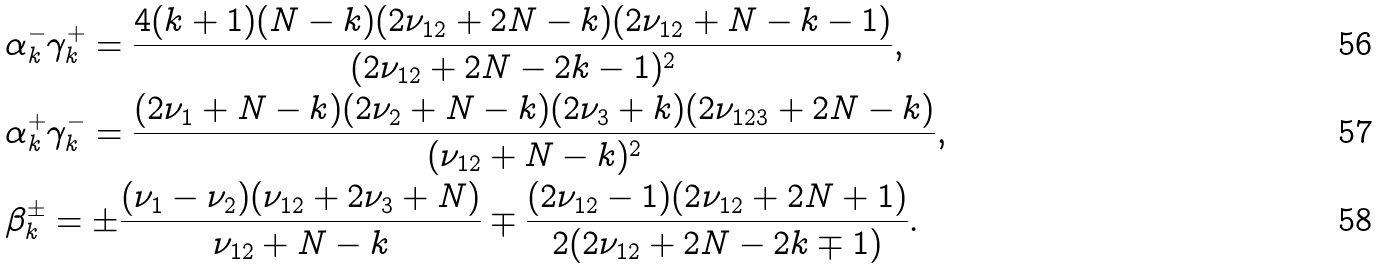Convert formula to latex. <formula><loc_0><loc_0><loc_500><loc_500>& \alpha ^ { - } _ { k } \gamma _ { k } ^ { + } = \frac { 4 ( k + 1 ) ( N - k ) ( 2 \nu _ { 1 2 } + 2 N - k ) ( 2 \nu _ { 1 2 } + N - k - 1 ) } { ( 2 \nu _ { 1 2 } + 2 N - 2 k - 1 ) ^ { 2 } } , \\ & \alpha ^ { + } _ { k } \gamma _ { k } ^ { - } = \frac { ( 2 \nu _ { 1 } + N - k ) ( 2 \nu _ { 2 } + N - k ) ( 2 \nu _ { 3 } + k ) ( 2 \nu _ { 1 2 3 } + 2 N - k ) } { ( \nu _ { 1 2 } + N - k ) ^ { 2 } } , \\ & \beta ^ { \pm } _ { k } = \pm \frac { ( \nu _ { 1 } - \nu _ { 2 } ) ( \nu _ { 1 2 } + 2 \nu _ { 3 } + N ) } { \nu _ { 1 2 } + N - k } \mp \frac { ( 2 \nu _ { 1 2 } - 1 ) ( 2 \nu _ { 1 2 } + 2 N + 1 ) } { 2 ( 2 \nu _ { 1 2 } + 2 N - 2 k \mp 1 ) } .</formula> 